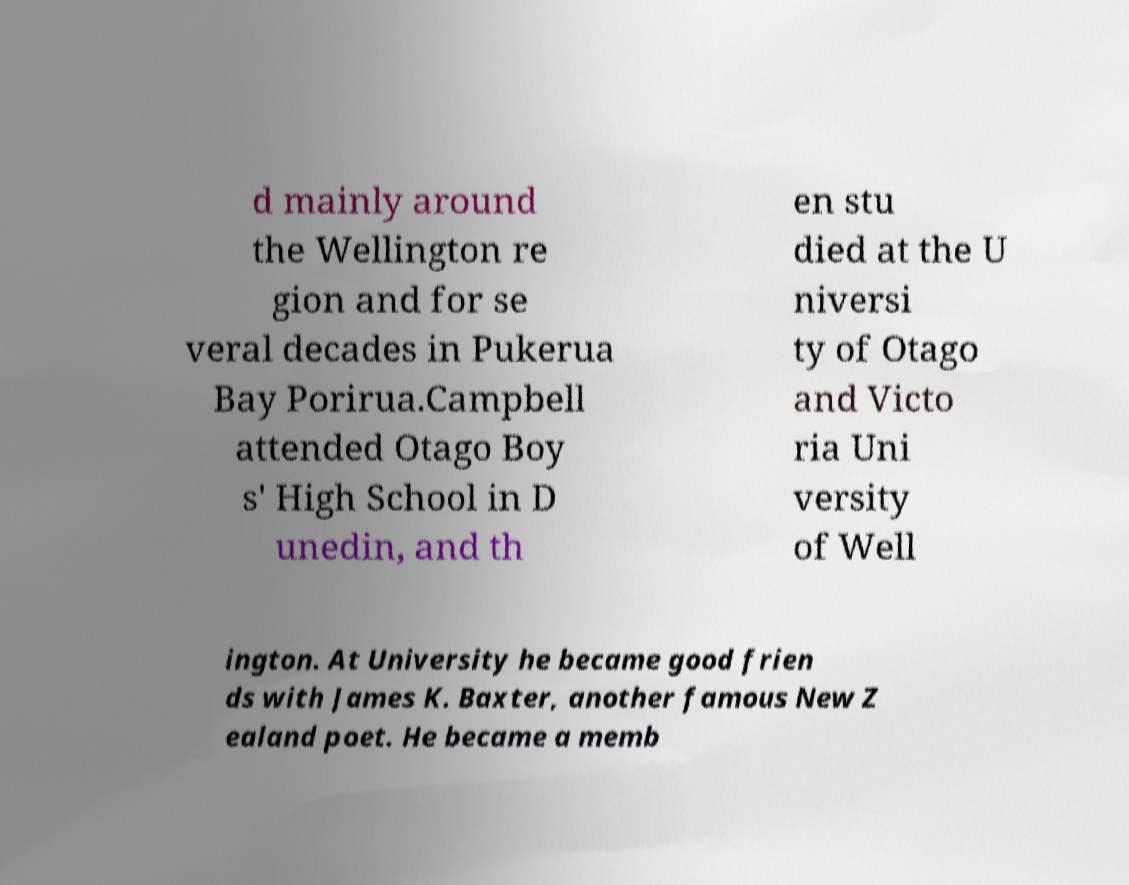Can you read and provide the text displayed in the image?This photo seems to have some interesting text. Can you extract and type it out for me? d mainly around the Wellington re gion and for se veral decades in Pukerua Bay Porirua.Campbell attended Otago Boy s' High School in D unedin, and th en stu died at the U niversi ty of Otago and Victo ria Uni versity of Well ington. At University he became good frien ds with James K. Baxter, another famous New Z ealand poet. He became a memb 